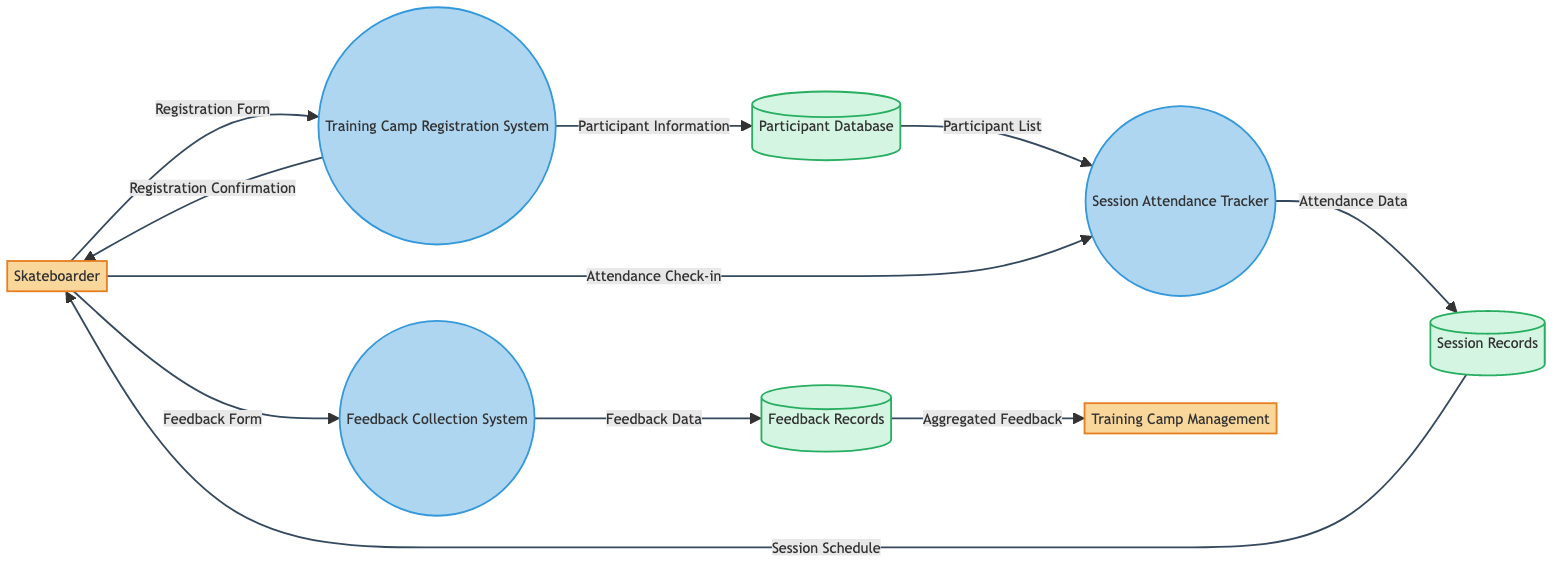What entity initiates the training camp registration? The diagram shows that the "Skateboarder" is the entity that sends the "Registration Form" to the "Training Camp Registration System," indicating that they initiate the registration process.
Answer: Skateboarder How many processes are there in the diagram? The diagram depicts three processes: "Training Camp Registration System," "Session Attendance Tracker," and "Feedback Collection System," totaling three processes.
Answer: Three What data is generated by the "Training Camp Registration System"? According to the flow from the "Training Camp Registration System," it outputs "Participant Information" to the "Participant Database," and sends "Registration Confirmation" back to the "Skateboarder." Therefore, the data generated includes both "Participant Information" and "Registration Confirmation."
Answer: Participant Information, Registration Confirmation What happens after the "Feedback Collection System" processes the data? The "Feedback Collection System" outputs "Feedback Data" to the "Feedback Records," which implies that the feedback collected gets stored in the feedback records.
Answer: Feedback Records Which data flow occurs after the skateboarder checks in for a session? The flow indicates that after the "Skateboarder" checks in for attendance by sending "Attendance Check-in" to the "Session Attendance Tracker," it subsequently sends "Attendance Data" to the "Session Records."
Answer: Attendance Data What information does the "Session Records" provide back to the skateboarder? The "Session Records" flow indicates it sends "Session Schedule" back to the "Skateboarder," meaning the skateboarder receives their schedule for the sessions attended.
Answer: Session Schedule What is the final output of the "Feedback Records" to be utilized? The "Feedback Records" aggregate data and send "Aggregated Feedback" to the "Training Camp Management," indicating this is a summarized form of feedback provided for management use.
Answer: Aggregated Feedback 